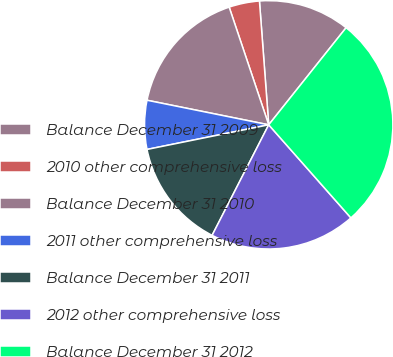Convert chart to OTSL. <chart><loc_0><loc_0><loc_500><loc_500><pie_chart><fcel>Balance December 31 2009<fcel>2010 other comprehensive loss<fcel>Balance December 31 2010<fcel>2011 other comprehensive loss<fcel>Balance December 31 2011<fcel>2012 other comprehensive loss<fcel>Balance December 31 2012<nl><fcel>11.9%<fcel>3.97%<fcel>16.67%<fcel>6.35%<fcel>14.29%<fcel>19.05%<fcel>27.78%<nl></chart> 